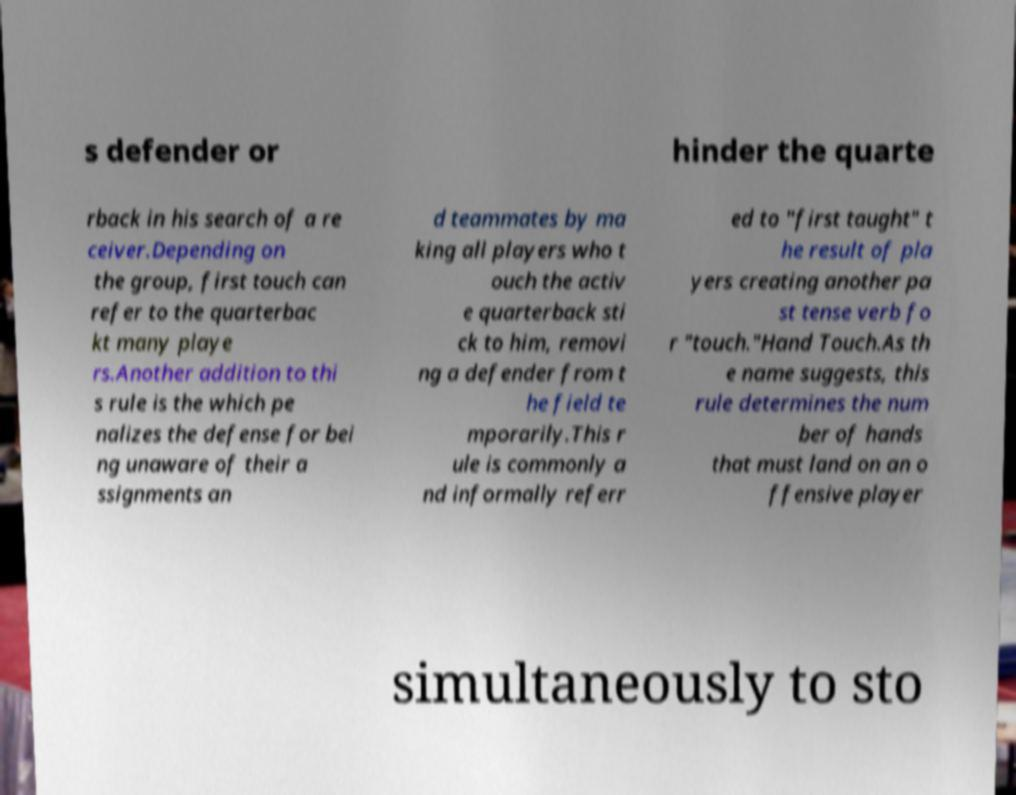Could you extract and type out the text from this image? s defender or hinder the quarte rback in his search of a re ceiver.Depending on the group, first touch can refer to the quarterbac kt many playe rs.Another addition to thi s rule is the which pe nalizes the defense for bei ng unaware of their a ssignments an d teammates by ma king all players who t ouch the activ e quarterback sti ck to him, removi ng a defender from t he field te mporarily.This r ule is commonly a nd informally referr ed to "first taught" t he result of pla yers creating another pa st tense verb fo r "touch."Hand Touch.As th e name suggests, this rule determines the num ber of hands that must land on an o ffensive player simultaneously to sto 